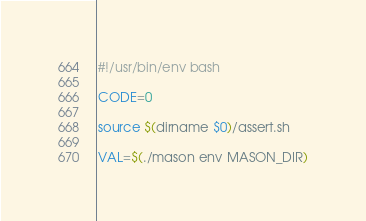Convert code to text. <code><loc_0><loc_0><loc_500><loc_500><_Bash_>#!/usr/bin/env bash

CODE=0

source $(dirname $0)/assert.sh

VAL=$(./mason env MASON_DIR)</code> 